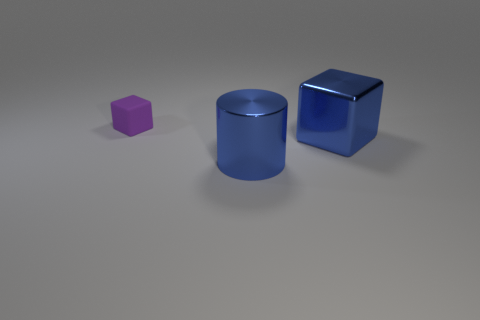Add 2 blue metallic things. How many objects exist? 5 Subtract all blocks. How many objects are left? 1 Subtract all big green things. Subtract all metal cylinders. How many objects are left? 2 Add 1 big blue blocks. How many big blue blocks are left? 2 Add 1 matte balls. How many matte balls exist? 1 Subtract 0 brown blocks. How many objects are left? 3 